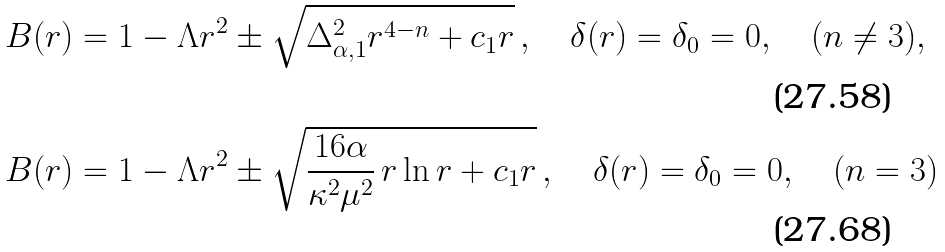<formula> <loc_0><loc_0><loc_500><loc_500>& B ( r ) = 1 - \Lambda r ^ { 2 } \pm \sqrt { \Delta _ { \alpha , 1 } ^ { 2 } r ^ { 4 - n } + c _ { 1 } r } \, , \quad \delta ( r ) = \delta _ { 0 } = 0 , \quad ( n \neq 3 ) , \\ & B ( r ) = 1 - \Lambda r ^ { 2 } \pm \sqrt { \frac { 1 6 \alpha } { \kappa ^ { 2 } \mu ^ { 2 } } \, r \ln r + c _ { 1 } r } \, , \quad \delta ( r ) = \delta _ { 0 } = 0 , \quad ( n = 3 )</formula> 